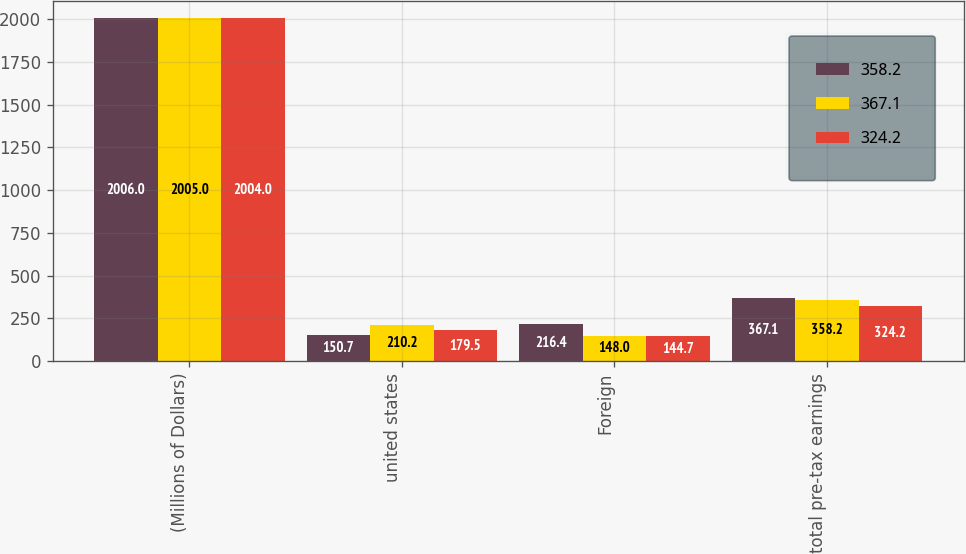Convert chart to OTSL. <chart><loc_0><loc_0><loc_500><loc_500><stacked_bar_chart><ecel><fcel>(Millions of Dollars)<fcel>united states<fcel>Foreign<fcel>total pre-tax earnings<nl><fcel>358.2<fcel>2006<fcel>150.7<fcel>216.4<fcel>367.1<nl><fcel>367.1<fcel>2005<fcel>210.2<fcel>148<fcel>358.2<nl><fcel>324.2<fcel>2004<fcel>179.5<fcel>144.7<fcel>324.2<nl></chart> 